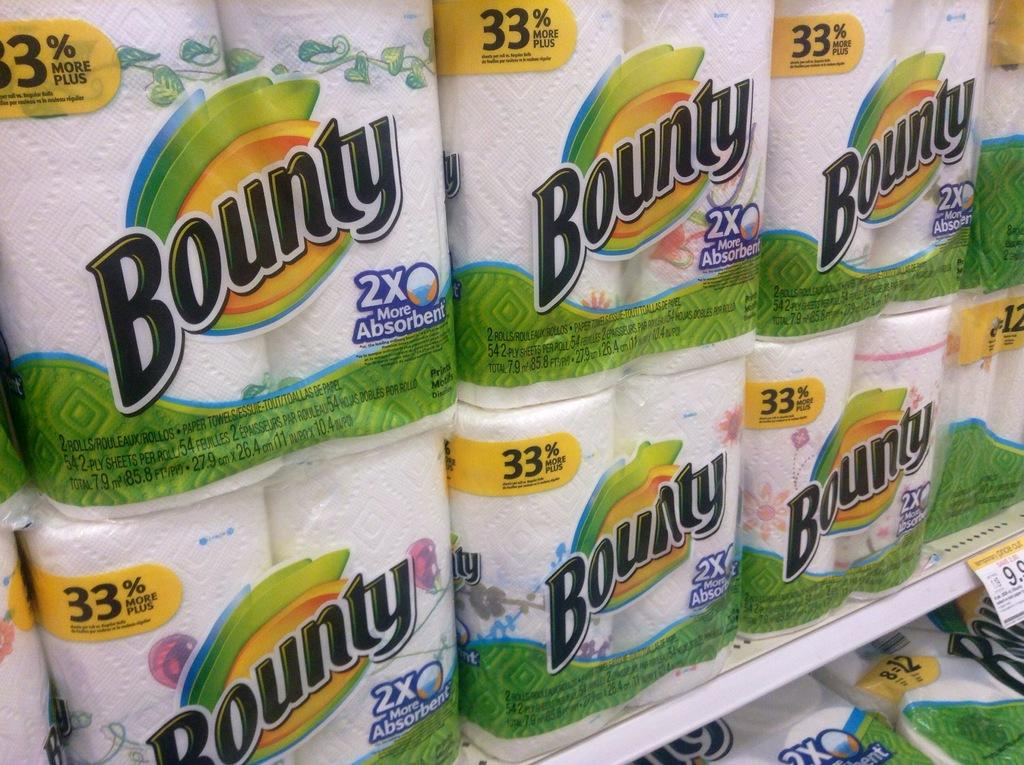What type of product is displayed on the rack in the image? There are tissue papers on a rack in the image. How are the tissue papers arranged on the rack? The tissue papers are on a rack in the image. Is there any information about the price of the tissue papers in the image? Yes, the price of the tissue papers is attached to the rack in the image. What type of marble is visible in the image? There is no marble present in the image. Can you see the parent of the person who placed the tissue papers on the rack in the image? There is no person or parent visible in the image; it only shows tissue papers on a rack with a price attached. 